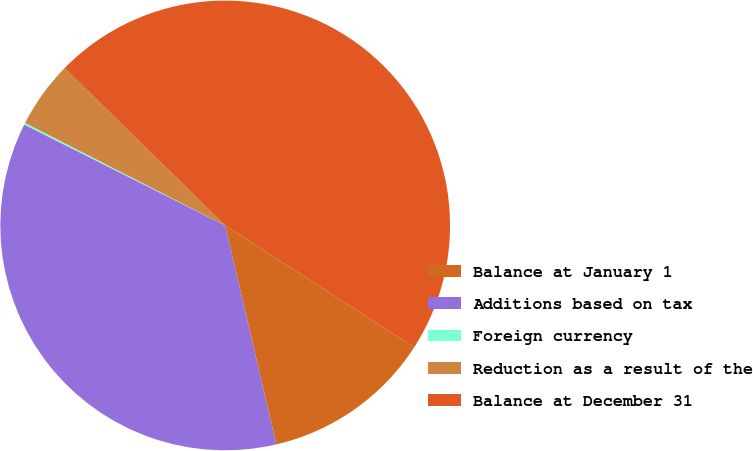<chart> <loc_0><loc_0><loc_500><loc_500><pie_chart><fcel>Balance at January 1<fcel>Additions based on tax<fcel>Foreign currency<fcel>Reduction as a result of the<fcel>Balance at December 31<nl><fcel>12.23%<fcel>36.06%<fcel>0.13%<fcel>4.8%<fcel>46.78%<nl></chart> 